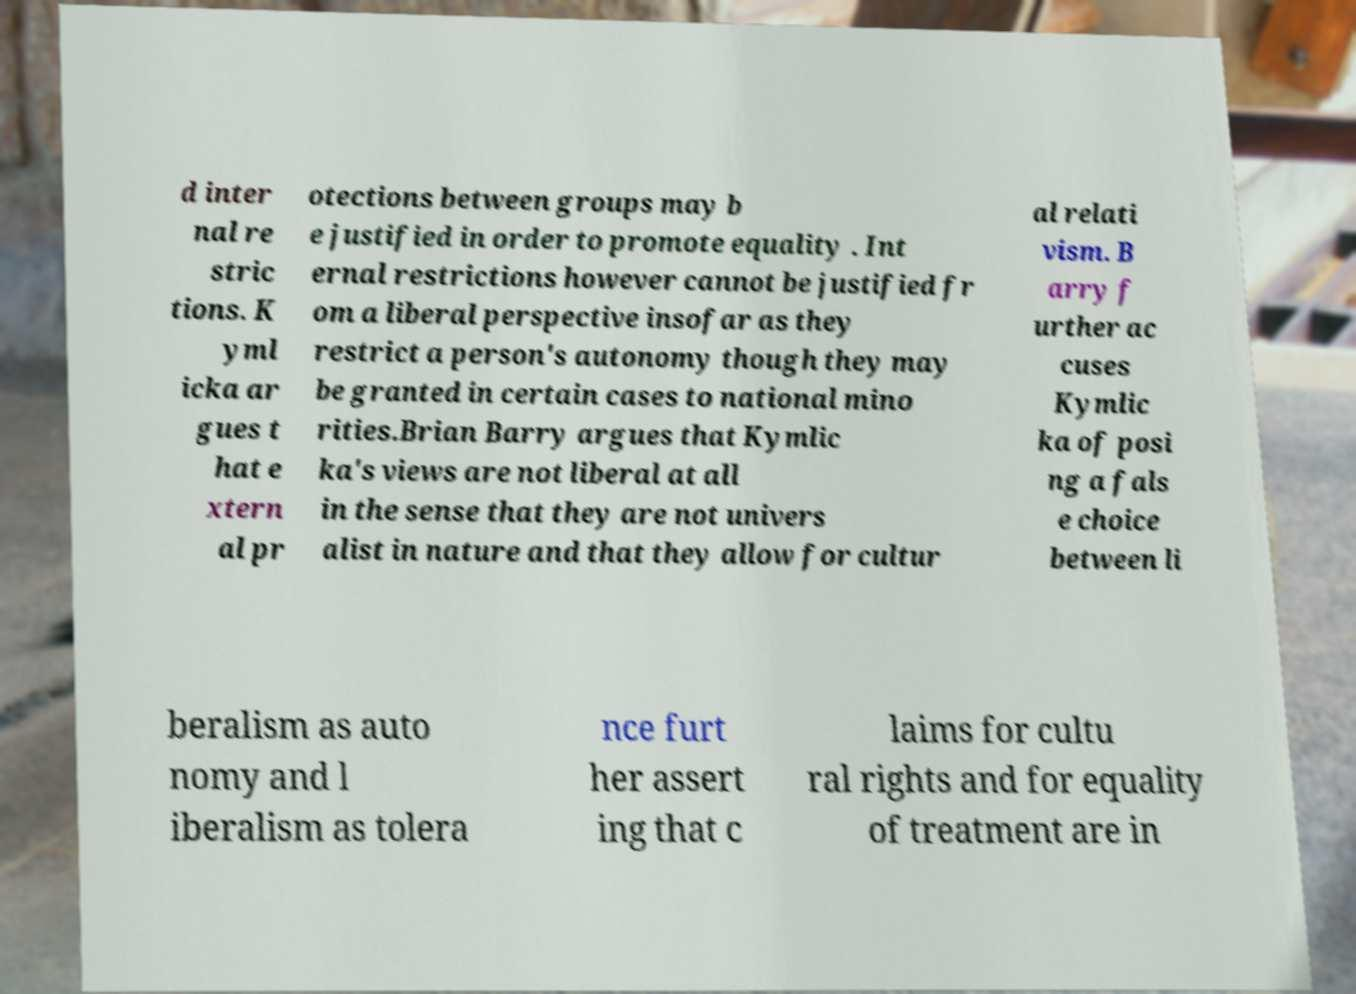Could you extract and type out the text from this image? d inter nal re stric tions. K yml icka ar gues t hat e xtern al pr otections between groups may b e justified in order to promote equality . Int ernal restrictions however cannot be justified fr om a liberal perspective insofar as they restrict a person's autonomy though they may be granted in certain cases to national mino rities.Brian Barry argues that Kymlic ka's views are not liberal at all in the sense that they are not univers alist in nature and that they allow for cultur al relati vism. B arry f urther ac cuses Kymlic ka of posi ng a fals e choice between li beralism as auto nomy and l iberalism as tolera nce furt her assert ing that c laims for cultu ral rights and for equality of treatment are in 